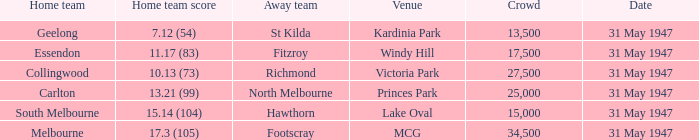What is the listed crowd when hawthorn is away? 1.0. 